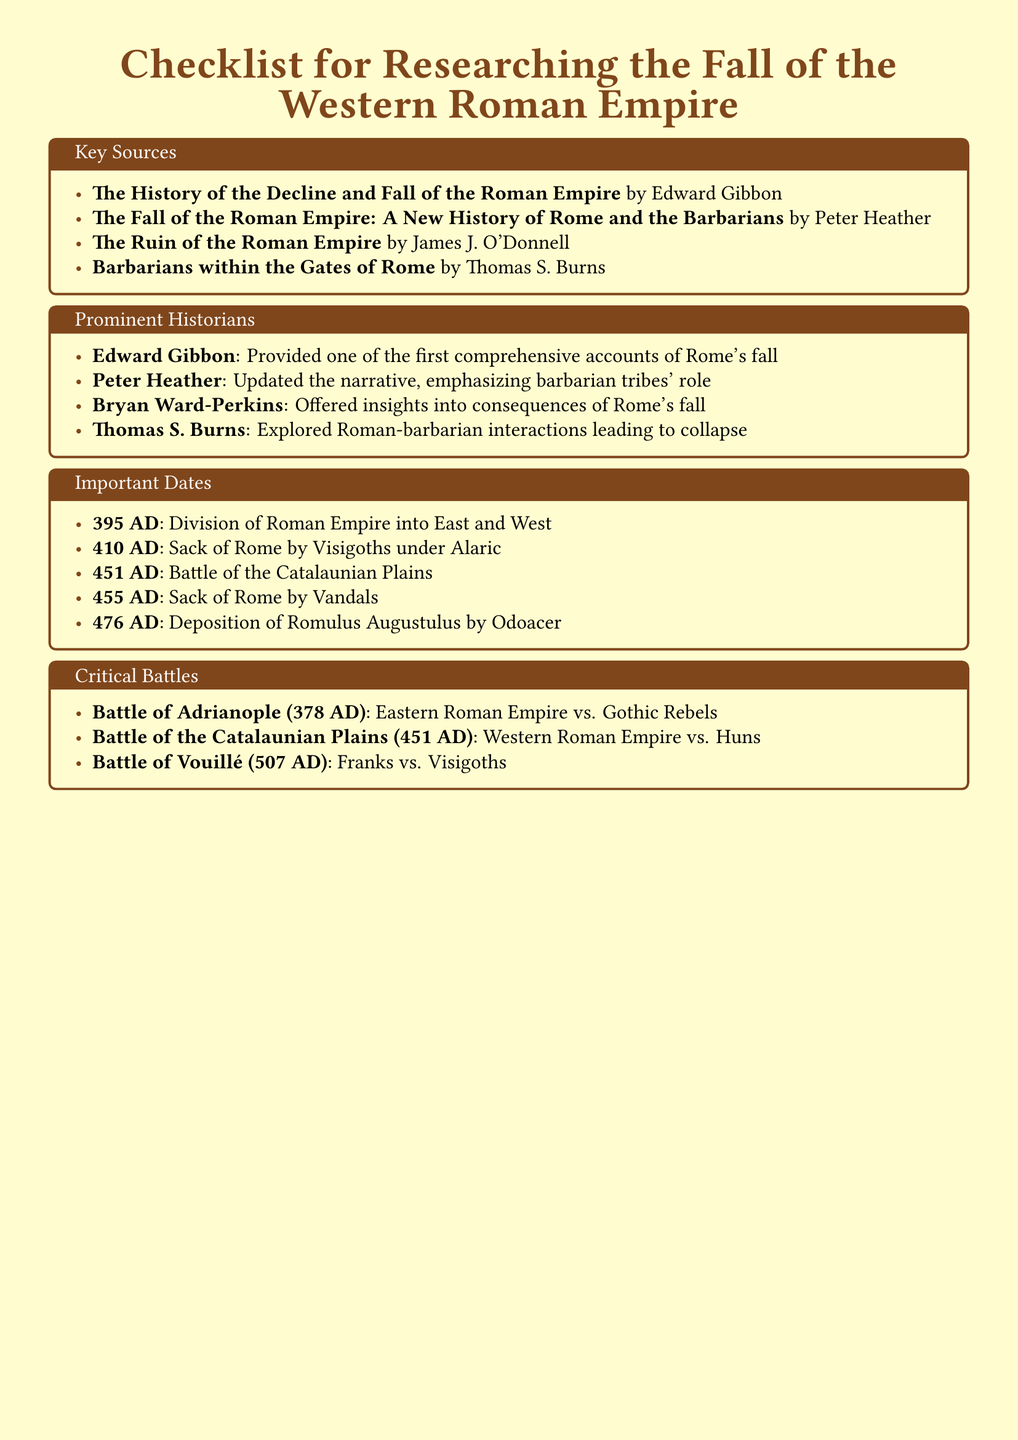What is the title of Edward Gibbon's work? The document lists "The History of the Decline and Fall of the Roman Empire" as Edward Gibbon's work.
Answer: The History of the Decline and Fall of the Roman Empire What significant event occurred in 410 AD? The document states that the Sack of Rome by Visigoths under Alaric happened in 410 AD.
Answer: Sack of Rome by Visigoths under Alaric Who is the historian that emphasizes barbarian tribes' role? Peter Heather is highlighted in the document for updating the narrative and emphasizing barbarian tribes' role in the fall of the Roman Empire.
Answer: Peter Heather What battle took place in 378 AD? The document mentions the Battle of Adrianople as taking place in 378 AD.
Answer: Battle of Adrianople Which historian provided one of the first comprehensive accounts of Rome's fall? The document identifies Edward Gibbon as the historian who provided one of the first comprehensive accounts.
Answer: Edward Gibbon What year marks the deposition of Romulus Augustulus? According to the document, the deposition of Romulus Augustulus occurred in 476 AD.
Answer: 476 AD What was the outcome of the Battle of Vouillé? The document mentions that the Franks fought against the Visigoths in the Battle of Vouillé.
Answer: Franks vs. Visigoths What event occurred in 395 AD? The document states that 395 AD marks the division of the Roman Empire into East and West.
Answer: Division of Roman Empire into East and West 